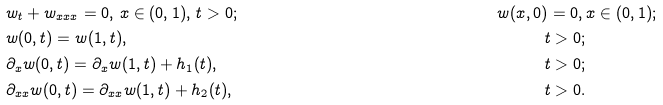<formula> <loc_0><loc_0><loc_500><loc_500>& w _ { t } + w _ { x x x } = 0 , \, x \in ( 0 , 1 ) , \, t > 0 ; & w ( x , 0 ) = 0 , \, & x \in ( 0 , 1 ) ; \\ & w ( 0 , t ) = w ( 1 , t ) , \quad & t > 0 ; & \\ & \partial _ { x } w ( 0 , t ) = \partial _ { x } w ( 1 , t ) + h _ { 1 } ( t ) , \quad & t > 0 ; & \\ & \partial _ { x x } w ( 0 , t ) = \partial _ { x x } w ( 1 , t ) + h _ { 2 } ( t ) , & t > 0 . &</formula> 